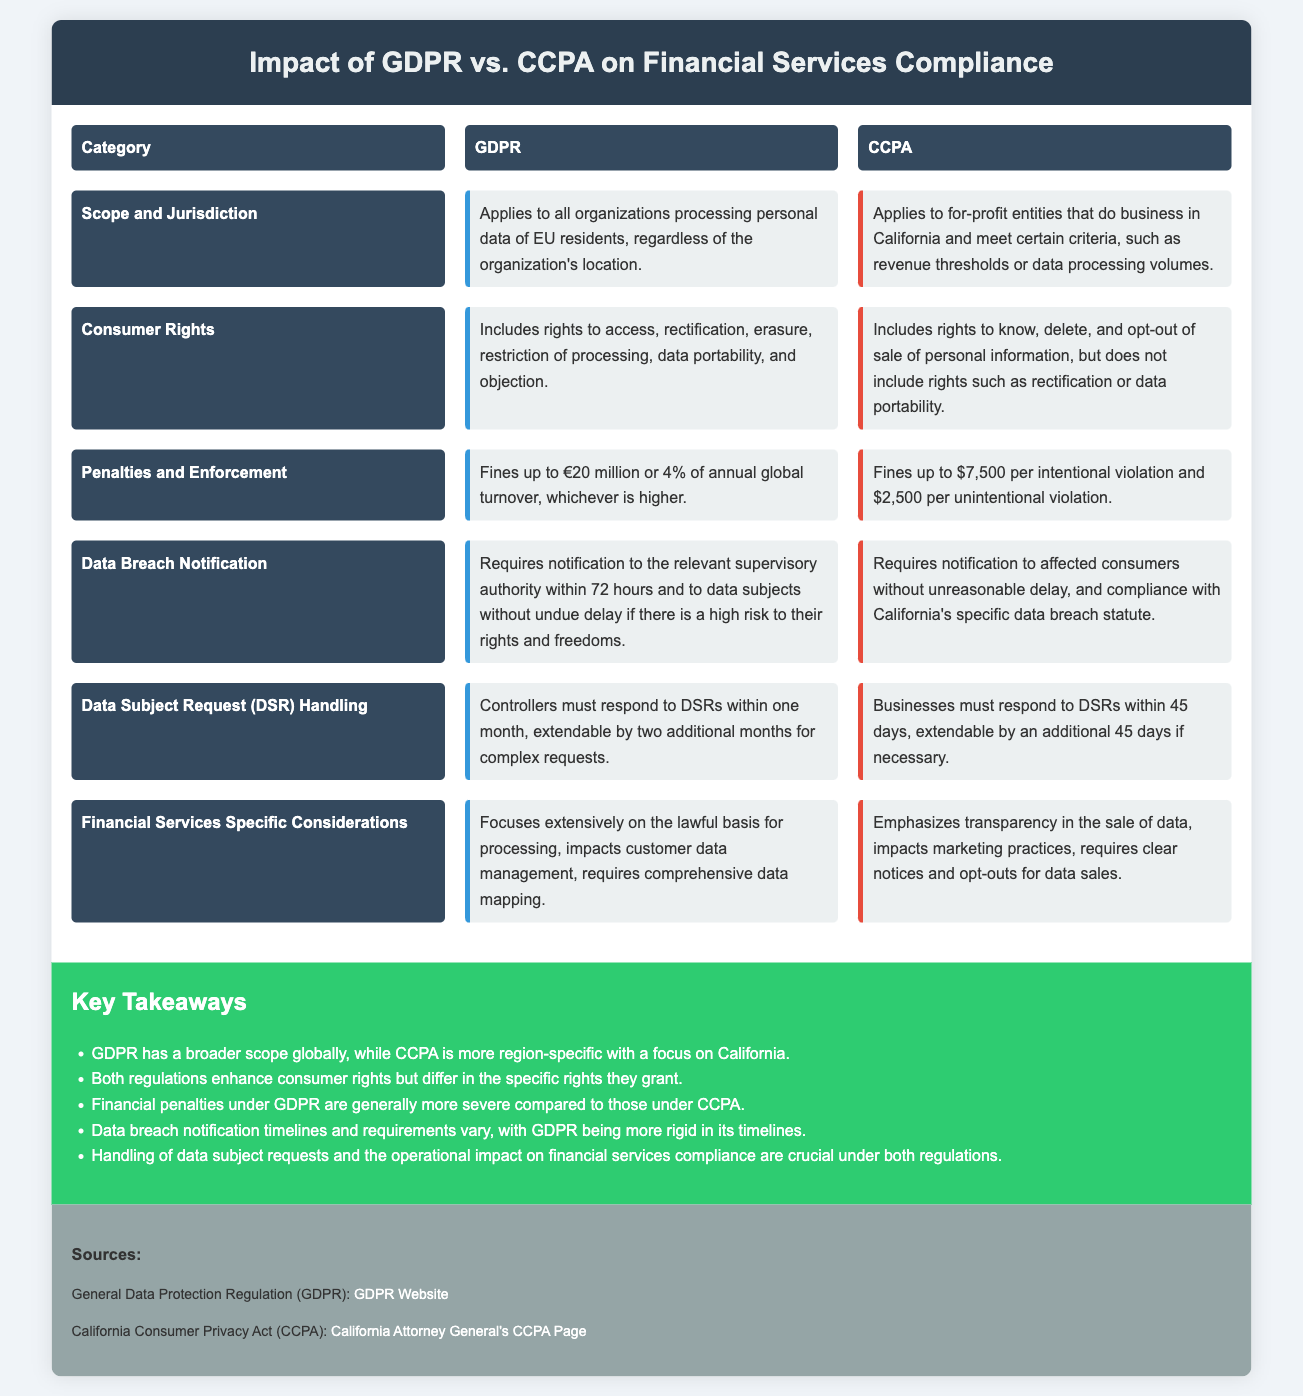What is the scope of GDPR? GDPR applies to all organizations processing personal data of EU residents, regardless of the organization's location.
Answer: All organizations processing personal data of EU residents What are the penalties under CCPA? CCPA fines are up to $7,500 per intentional violation and $2,500 per unintentional violation.
Answer: Up to $7,500 / $2,500 How long do organizations have to notify a data breach under GDPR? GDPR requires notifications to the relevant supervisory authority within 72 hours of a data breach.
Answer: 72 hours What rights are included under CCPA? CCPA includes rights to know, delete, and opt-out of the sale of personal information.
Answer: Know, delete, opt-out Which regulation has more severe financial penalties? The document states that financial penalties under GDPR are generally more severe compared to those under CCPA.
Answer: GDPR How long do businesses have to respond to data subject requests under CCPA? CCPA requires businesses to respond to data subject requests within 45 days, extendable by an additional 45 days if necessary.
Answer: 45 days What does GDPR emphasize on for financial services? GDPR focuses extensively on the lawful basis for processing, impacts customer data management, and requires comprehensive data mapping.
Answer: Lawful basis for processing What is a key takeaway regarding consumer rights? Both regulations enhance consumer rights but differ in the specific rights they grant.
Answer: They differ in rights granted 